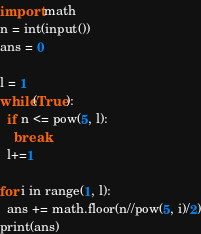Convert code to text. <code><loc_0><loc_0><loc_500><loc_500><_Python_>import math
n = int(input())
ans = 0

l = 1
while(True):
  if n <= pow(5, l):
    break
  l+=1

for i in range(1, l):
  ans += math.floor(n//pow(5, i)/2)
print(ans)</code> 